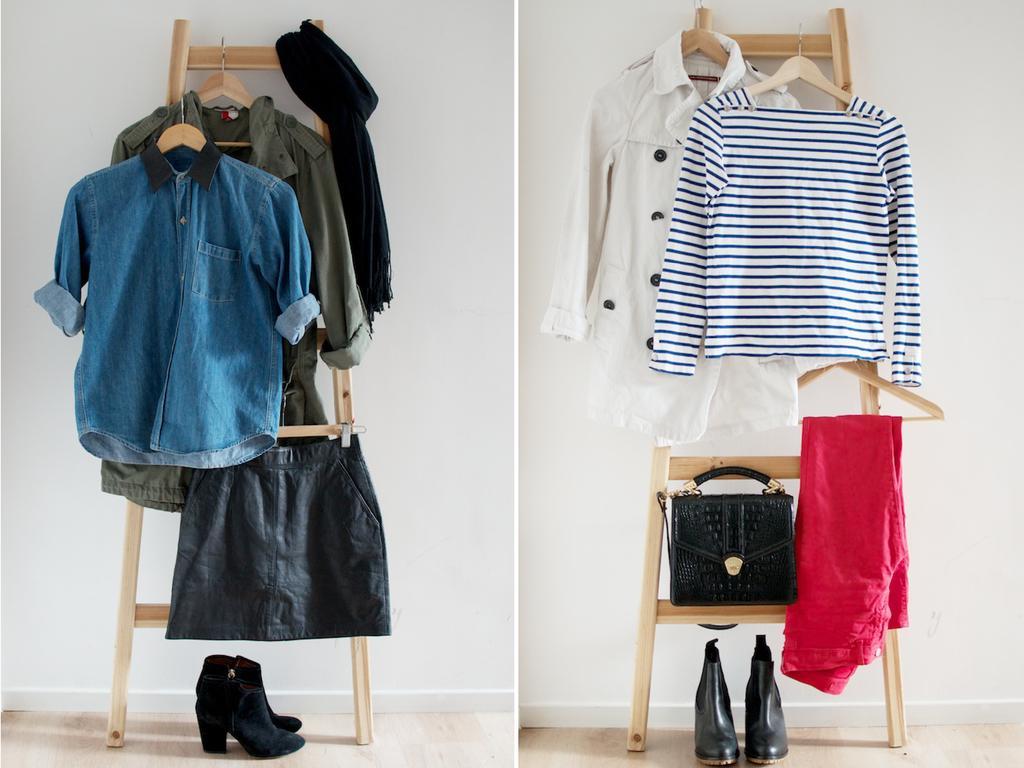Can you describe this image briefly? In this image, few clothes are hanging to the wooden poles. Blue color,ash color, t shirt ,shirt, bag , red, boots, short. And back side, white color wall. Bottom floor. 